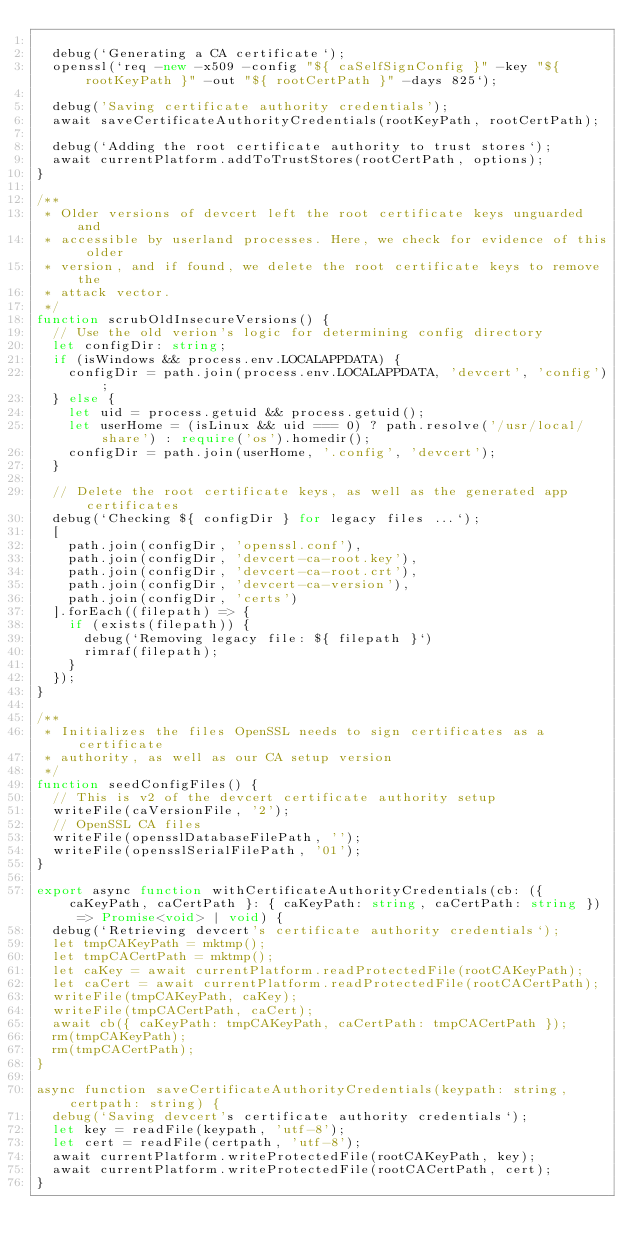Convert code to text. <code><loc_0><loc_0><loc_500><loc_500><_TypeScript_>
  debug(`Generating a CA certificate`);
  openssl(`req -new -x509 -config "${ caSelfSignConfig }" -key "${ rootKeyPath }" -out "${ rootCertPath }" -days 825`);

  debug('Saving certificate authority credentials');
  await saveCertificateAuthorityCredentials(rootKeyPath, rootCertPath);

  debug(`Adding the root certificate authority to trust stores`);
  await currentPlatform.addToTrustStores(rootCertPath, options);
}

/**
 * Older versions of devcert left the root certificate keys unguarded and
 * accessible by userland processes. Here, we check for evidence of this older
 * version, and if found, we delete the root certificate keys to remove the
 * attack vector.
 */
function scrubOldInsecureVersions() {
  // Use the old verion's logic for determining config directory
  let configDir: string;
  if (isWindows && process.env.LOCALAPPDATA) {
    configDir = path.join(process.env.LOCALAPPDATA, 'devcert', 'config');
  } else {
    let uid = process.getuid && process.getuid();
    let userHome = (isLinux && uid === 0) ? path.resolve('/usr/local/share') : require('os').homedir();
    configDir = path.join(userHome, '.config', 'devcert');
  }

  // Delete the root certificate keys, as well as the generated app certificates
  debug(`Checking ${ configDir } for legacy files ...`);
  [
    path.join(configDir, 'openssl.conf'),
    path.join(configDir, 'devcert-ca-root.key'),
    path.join(configDir, 'devcert-ca-root.crt'),
    path.join(configDir, 'devcert-ca-version'),
    path.join(configDir, 'certs')
  ].forEach((filepath) => {
    if (exists(filepath)) {
      debug(`Removing legacy file: ${ filepath }`)
      rimraf(filepath);
    }
  });
}

/**
 * Initializes the files OpenSSL needs to sign certificates as a certificate
 * authority, as well as our CA setup version
 */
function seedConfigFiles() {
  // This is v2 of the devcert certificate authority setup
  writeFile(caVersionFile, '2');
  // OpenSSL CA files
  writeFile(opensslDatabaseFilePath, '');
  writeFile(opensslSerialFilePath, '01');
}

export async function withCertificateAuthorityCredentials(cb: ({ caKeyPath, caCertPath }: { caKeyPath: string, caCertPath: string }) => Promise<void> | void) {
  debug(`Retrieving devcert's certificate authority credentials`);
  let tmpCAKeyPath = mktmp();
  let tmpCACertPath = mktmp();
  let caKey = await currentPlatform.readProtectedFile(rootCAKeyPath);
  let caCert = await currentPlatform.readProtectedFile(rootCACertPath);
  writeFile(tmpCAKeyPath, caKey);
  writeFile(tmpCACertPath, caCert);
  await cb({ caKeyPath: tmpCAKeyPath, caCertPath: tmpCACertPath });
  rm(tmpCAKeyPath);
  rm(tmpCACertPath);
}

async function saveCertificateAuthorityCredentials(keypath: string, certpath: string) {
  debug(`Saving devcert's certificate authority credentials`);
  let key = readFile(keypath, 'utf-8');
  let cert = readFile(certpath, 'utf-8');
  await currentPlatform.writeProtectedFile(rootCAKeyPath, key);
  await currentPlatform.writeProtectedFile(rootCACertPath, cert);
}
</code> 